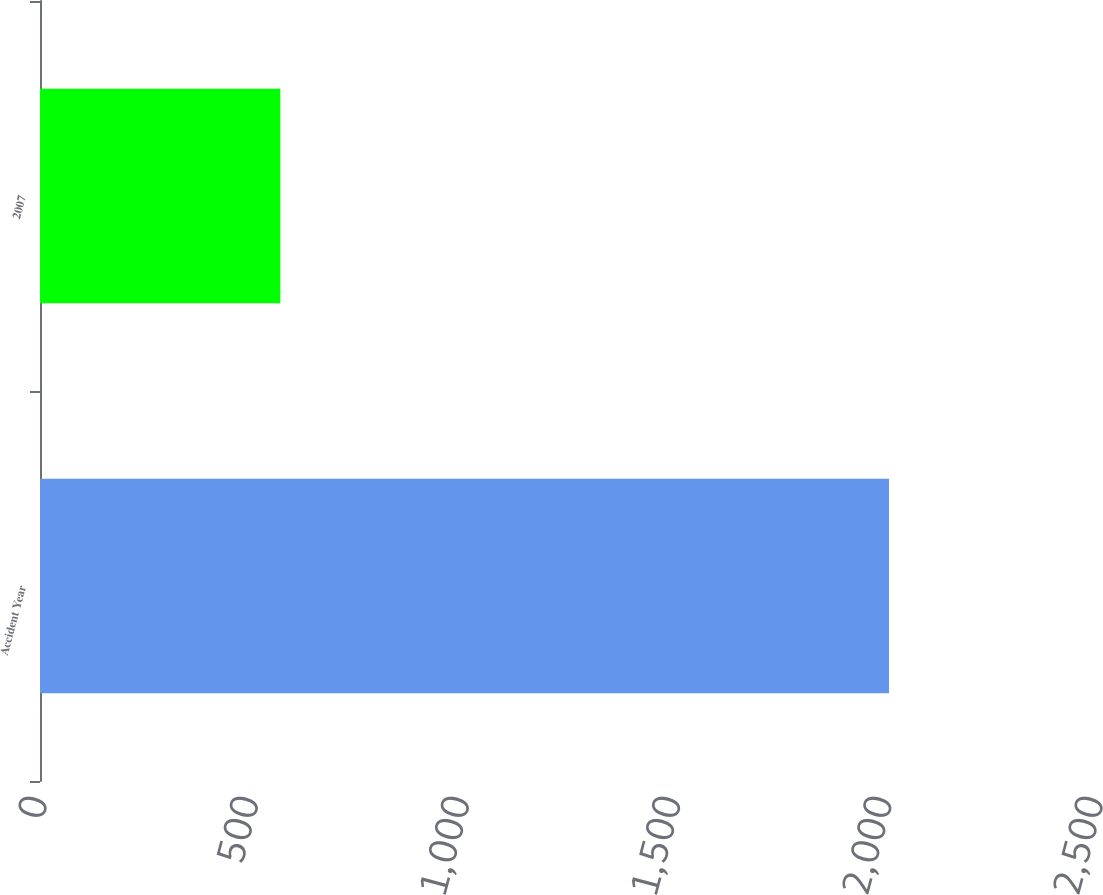Convert chart to OTSL. <chart><loc_0><loc_0><loc_500><loc_500><bar_chart><fcel>Accident Year<fcel>2007<nl><fcel>2010<fcel>569<nl></chart> 